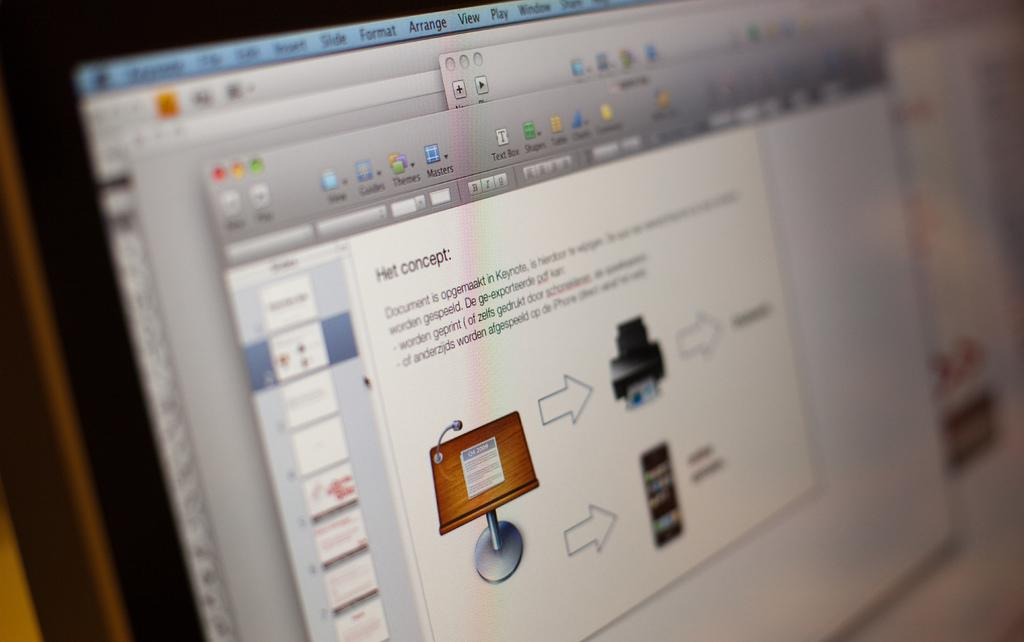<image>
Offer a succinct explanation of the picture presented. A slide presentation is displaying a slide with a header that says Het concept. 